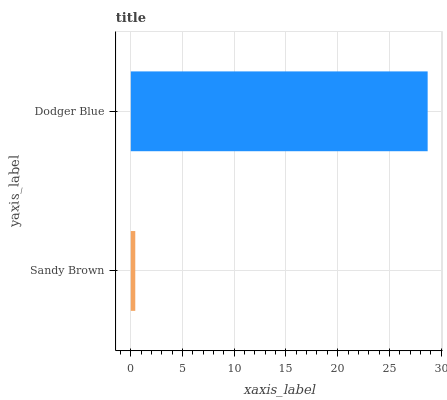Is Sandy Brown the minimum?
Answer yes or no. Yes. Is Dodger Blue the maximum?
Answer yes or no. Yes. Is Dodger Blue the minimum?
Answer yes or no. No. Is Dodger Blue greater than Sandy Brown?
Answer yes or no. Yes. Is Sandy Brown less than Dodger Blue?
Answer yes or no. Yes. Is Sandy Brown greater than Dodger Blue?
Answer yes or no. No. Is Dodger Blue less than Sandy Brown?
Answer yes or no. No. Is Dodger Blue the high median?
Answer yes or no. Yes. Is Sandy Brown the low median?
Answer yes or no. Yes. Is Sandy Brown the high median?
Answer yes or no. No. Is Dodger Blue the low median?
Answer yes or no. No. 